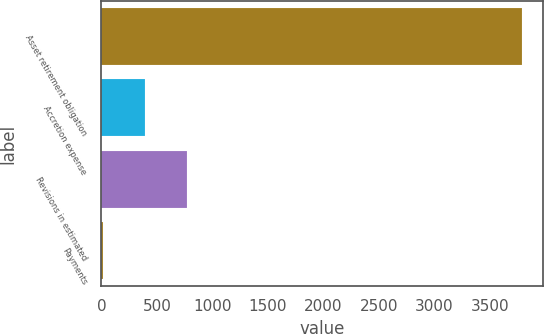<chart> <loc_0><loc_0><loc_500><loc_500><bar_chart><fcel>Asset retirement obligation<fcel>Accretion expense<fcel>Revisions in estimated<fcel>Payments<nl><fcel>3788<fcel>394.1<fcel>771.2<fcel>17<nl></chart> 